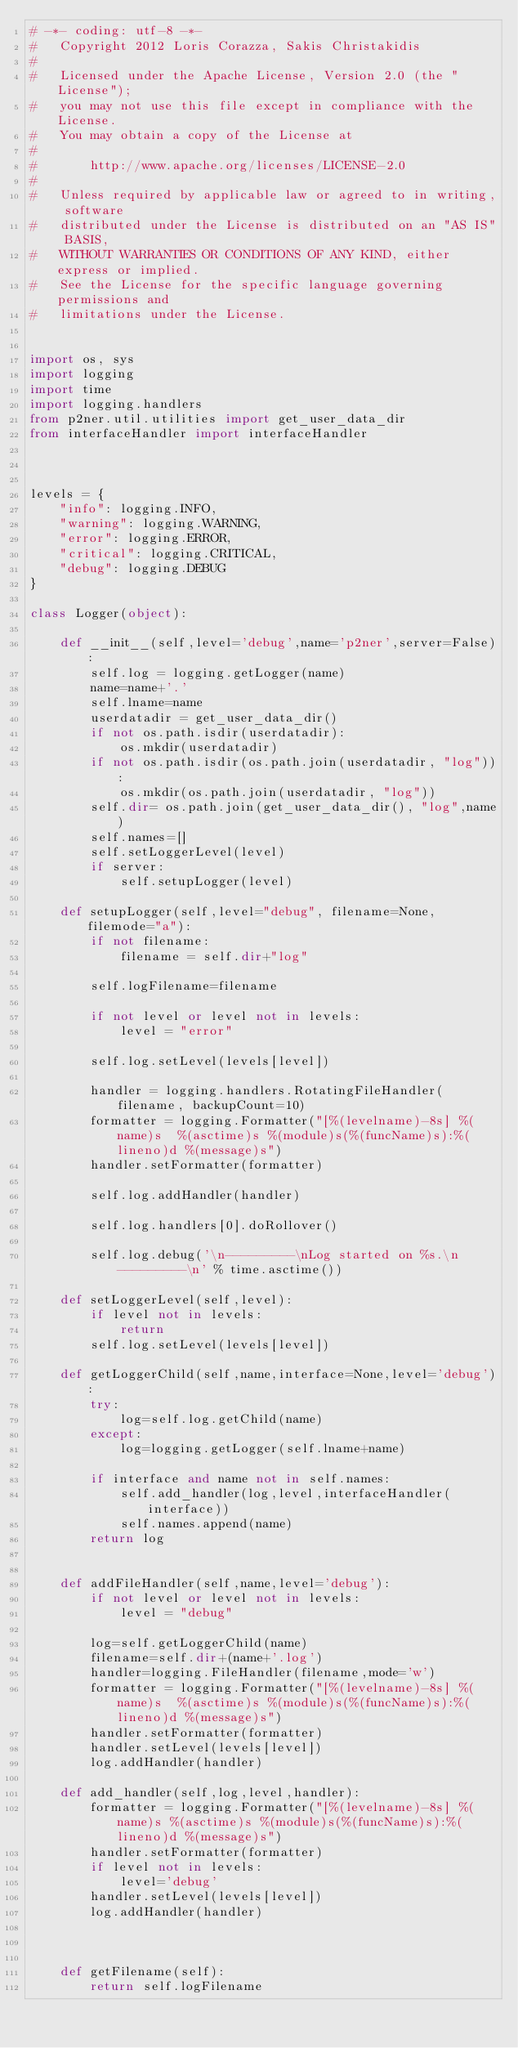<code> <loc_0><loc_0><loc_500><loc_500><_Python_># -*- coding: utf-8 -*-
#   Copyright 2012 Loris Corazza, Sakis Christakidis
#
#   Licensed under the Apache License, Version 2.0 (the "License");
#   you may not use this file except in compliance with the License.
#   You may obtain a copy of the License at
#
#       http://www.apache.org/licenses/LICENSE-2.0
#
#   Unless required by applicable law or agreed to in writing, software
#   distributed under the License is distributed on an "AS IS" BASIS,
#   WITHOUT WARRANTIES OR CONDITIONS OF ANY KIND, either express or implied.
#   See the License for the specific language governing permissions and
#   limitations under the License.


import os, sys
import logging
import time
import logging.handlers
from p2ner.util.utilities import get_user_data_dir
from interfaceHandler import interfaceHandler



levels = {
    "info": logging.INFO,
    "warning": logging.WARNING,
    "error": logging.ERROR,
    "critical": logging.CRITICAL,
    "debug": logging.DEBUG
}

class Logger(object):

    def __init__(self,level='debug',name='p2ner',server=False):
        self.log = logging.getLogger(name)
        name=name+'.'
        self.lname=name
        userdatadir = get_user_data_dir()
        if not os.path.isdir(userdatadir):
            os.mkdir(userdatadir)
        if not os.path.isdir(os.path.join(userdatadir, "log")):
            os.mkdir(os.path.join(userdatadir, "log"))
        self.dir= os.path.join(get_user_data_dir(), "log",name)
        self.names=[]
        self.setLoggerLevel(level)
        if server:
            self.setupLogger(level)

    def setupLogger(self,level="debug", filename=None, filemode="a"):
        if not filename:
            filename = self.dir+"log"

        self.logFilename=filename

        if not level or level not in levels:
            level = "error"

        self.log.setLevel(levels[level])

        handler = logging.handlers.RotatingFileHandler(filename, backupCount=10)
        formatter = logging.Formatter("[%(levelname)-8s] %(name)s  %(asctime)s %(module)s(%(funcName)s):%(lineno)d %(message)s")
        handler.setFormatter(formatter)

        self.log.addHandler(handler)

        self.log.handlers[0].doRollover()

        self.log.debug('\n---------\nLog started on %s.\n---------\n' % time.asctime())

    def setLoggerLevel(self,level):
        if level not in levels:
            return
        self.log.setLevel(levels[level])

    def getLoggerChild(self,name,interface=None,level='debug'):
        try:
            log=self.log.getChild(name)
        except:
            log=logging.getLogger(self.lname+name)

        if interface and name not in self.names:
            self.add_handler(log,level,interfaceHandler(interface))
            self.names.append(name)
        return log


    def addFileHandler(self,name,level='debug'):
        if not level or level not in levels:
            level = "debug"

        log=self.getLoggerChild(name)
        filename=self.dir+(name+'.log')
        handler=logging.FileHandler(filename,mode='w')
        formatter = logging.Formatter("[%(levelname)-8s] %(name)s  %(asctime)s %(module)s(%(funcName)s):%(lineno)d %(message)s")
        handler.setFormatter(formatter)
        handler.setLevel(levels[level])
        log.addHandler(handler)

    def add_handler(self,log,level,handler):
        formatter = logging.Formatter("[%(levelname)-8s] %(name)s %(asctime)s %(module)s(%(funcName)s):%(lineno)d %(message)s")
        handler.setFormatter(formatter)
        if level not in levels:
            level='debug'
        handler.setLevel(levels[level])
        log.addHandler(handler)



    def getFilename(self):
        return self.logFilename






</code> 